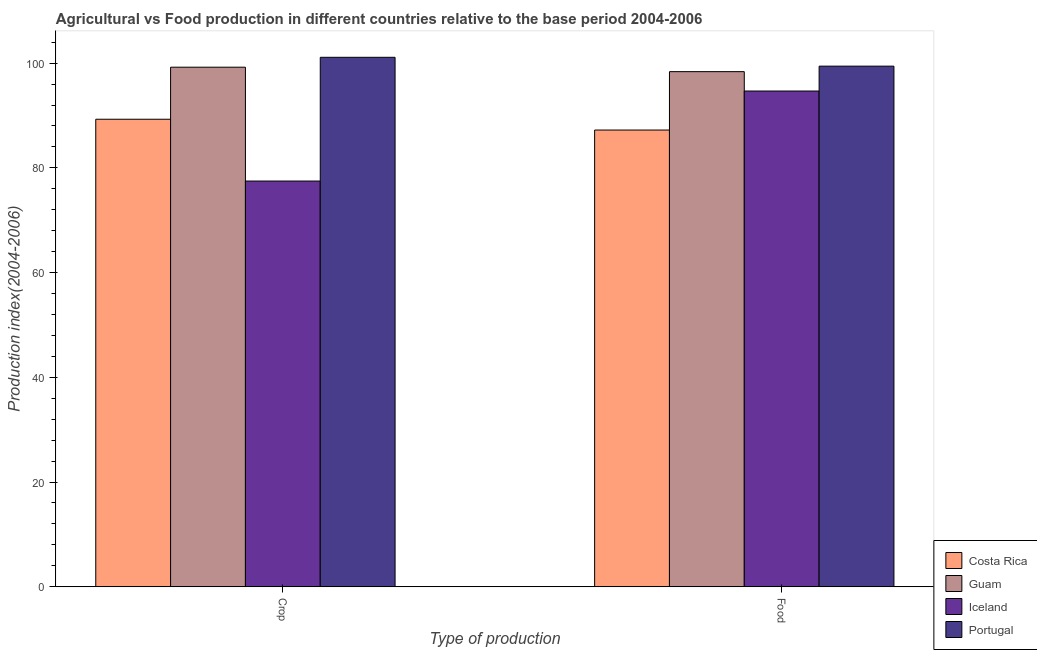Are the number of bars on each tick of the X-axis equal?
Your answer should be compact. Yes. How many bars are there on the 2nd tick from the right?
Offer a very short reply. 4. What is the label of the 2nd group of bars from the left?
Keep it short and to the point. Food. What is the food production index in Guam?
Make the answer very short. 98.37. Across all countries, what is the maximum crop production index?
Your response must be concise. 101.11. Across all countries, what is the minimum crop production index?
Provide a short and direct response. 77.48. What is the total crop production index in the graph?
Your answer should be compact. 367.09. What is the difference between the crop production index in Guam and that in Iceland?
Provide a succinct answer. 21.74. What is the difference between the food production index in Costa Rica and the crop production index in Guam?
Give a very brief answer. -12. What is the average crop production index per country?
Your answer should be compact. 91.77. What is the difference between the food production index and crop production index in Guam?
Offer a very short reply. -0.85. In how many countries, is the crop production index greater than 68 ?
Give a very brief answer. 4. What is the ratio of the food production index in Costa Rica to that in Iceland?
Keep it short and to the point. 0.92. Is the food production index in Guam less than that in Portugal?
Give a very brief answer. Yes. In how many countries, is the food production index greater than the average food production index taken over all countries?
Ensure brevity in your answer.  2. What does the 3rd bar from the left in Crop represents?
Offer a terse response. Iceland. Are all the bars in the graph horizontal?
Your answer should be very brief. No. How many countries are there in the graph?
Your answer should be compact. 4. Are the values on the major ticks of Y-axis written in scientific E-notation?
Offer a very short reply. No. How many legend labels are there?
Give a very brief answer. 4. What is the title of the graph?
Offer a terse response. Agricultural vs Food production in different countries relative to the base period 2004-2006. What is the label or title of the X-axis?
Make the answer very short. Type of production. What is the label or title of the Y-axis?
Make the answer very short. Production index(2004-2006). What is the Production index(2004-2006) in Costa Rica in Crop?
Give a very brief answer. 89.28. What is the Production index(2004-2006) of Guam in Crop?
Your response must be concise. 99.22. What is the Production index(2004-2006) in Iceland in Crop?
Give a very brief answer. 77.48. What is the Production index(2004-2006) in Portugal in Crop?
Provide a short and direct response. 101.11. What is the Production index(2004-2006) of Costa Rica in Food?
Make the answer very short. 87.22. What is the Production index(2004-2006) in Guam in Food?
Offer a very short reply. 98.37. What is the Production index(2004-2006) in Iceland in Food?
Offer a very short reply. 94.67. What is the Production index(2004-2006) in Portugal in Food?
Provide a succinct answer. 99.42. Across all Type of production, what is the maximum Production index(2004-2006) of Costa Rica?
Give a very brief answer. 89.28. Across all Type of production, what is the maximum Production index(2004-2006) in Guam?
Offer a terse response. 99.22. Across all Type of production, what is the maximum Production index(2004-2006) of Iceland?
Provide a succinct answer. 94.67. Across all Type of production, what is the maximum Production index(2004-2006) of Portugal?
Keep it short and to the point. 101.11. Across all Type of production, what is the minimum Production index(2004-2006) in Costa Rica?
Your answer should be very brief. 87.22. Across all Type of production, what is the minimum Production index(2004-2006) of Guam?
Offer a terse response. 98.37. Across all Type of production, what is the minimum Production index(2004-2006) of Iceland?
Provide a short and direct response. 77.48. Across all Type of production, what is the minimum Production index(2004-2006) in Portugal?
Your response must be concise. 99.42. What is the total Production index(2004-2006) in Costa Rica in the graph?
Offer a very short reply. 176.5. What is the total Production index(2004-2006) of Guam in the graph?
Provide a succinct answer. 197.59. What is the total Production index(2004-2006) of Iceland in the graph?
Your answer should be very brief. 172.15. What is the total Production index(2004-2006) in Portugal in the graph?
Your answer should be very brief. 200.53. What is the difference between the Production index(2004-2006) in Costa Rica in Crop and that in Food?
Your response must be concise. 2.06. What is the difference between the Production index(2004-2006) in Iceland in Crop and that in Food?
Provide a succinct answer. -17.19. What is the difference between the Production index(2004-2006) in Portugal in Crop and that in Food?
Offer a very short reply. 1.69. What is the difference between the Production index(2004-2006) in Costa Rica in Crop and the Production index(2004-2006) in Guam in Food?
Offer a terse response. -9.09. What is the difference between the Production index(2004-2006) of Costa Rica in Crop and the Production index(2004-2006) of Iceland in Food?
Offer a terse response. -5.39. What is the difference between the Production index(2004-2006) in Costa Rica in Crop and the Production index(2004-2006) in Portugal in Food?
Provide a succinct answer. -10.14. What is the difference between the Production index(2004-2006) in Guam in Crop and the Production index(2004-2006) in Iceland in Food?
Your response must be concise. 4.55. What is the difference between the Production index(2004-2006) in Guam in Crop and the Production index(2004-2006) in Portugal in Food?
Make the answer very short. -0.2. What is the difference between the Production index(2004-2006) of Iceland in Crop and the Production index(2004-2006) of Portugal in Food?
Ensure brevity in your answer.  -21.94. What is the average Production index(2004-2006) of Costa Rica per Type of production?
Provide a short and direct response. 88.25. What is the average Production index(2004-2006) of Guam per Type of production?
Make the answer very short. 98.8. What is the average Production index(2004-2006) in Iceland per Type of production?
Your answer should be very brief. 86.08. What is the average Production index(2004-2006) in Portugal per Type of production?
Provide a succinct answer. 100.27. What is the difference between the Production index(2004-2006) of Costa Rica and Production index(2004-2006) of Guam in Crop?
Your response must be concise. -9.94. What is the difference between the Production index(2004-2006) of Costa Rica and Production index(2004-2006) of Portugal in Crop?
Your answer should be compact. -11.83. What is the difference between the Production index(2004-2006) in Guam and Production index(2004-2006) in Iceland in Crop?
Provide a succinct answer. 21.74. What is the difference between the Production index(2004-2006) in Guam and Production index(2004-2006) in Portugal in Crop?
Offer a terse response. -1.89. What is the difference between the Production index(2004-2006) in Iceland and Production index(2004-2006) in Portugal in Crop?
Provide a succinct answer. -23.63. What is the difference between the Production index(2004-2006) in Costa Rica and Production index(2004-2006) in Guam in Food?
Your response must be concise. -11.15. What is the difference between the Production index(2004-2006) in Costa Rica and Production index(2004-2006) in Iceland in Food?
Give a very brief answer. -7.45. What is the difference between the Production index(2004-2006) in Guam and Production index(2004-2006) in Iceland in Food?
Give a very brief answer. 3.7. What is the difference between the Production index(2004-2006) in Guam and Production index(2004-2006) in Portugal in Food?
Ensure brevity in your answer.  -1.05. What is the difference between the Production index(2004-2006) of Iceland and Production index(2004-2006) of Portugal in Food?
Your response must be concise. -4.75. What is the ratio of the Production index(2004-2006) in Costa Rica in Crop to that in Food?
Keep it short and to the point. 1.02. What is the ratio of the Production index(2004-2006) in Guam in Crop to that in Food?
Your answer should be very brief. 1.01. What is the ratio of the Production index(2004-2006) of Iceland in Crop to that in Food?
Ensure brevity in your answer.  0.82. What is the ratio of the Production index(2004-2006) of Portugal in Crop to that in Food?
Your answer should be very brief. 1.02. What is the difference between the highest and the second highest Production index(2004-2006) of Costa Rica?
Your response must be concise. 2.06. What is the difference between the highest and the second highest Production index(2004-2006) of Guam?
Your response must be concise. 0.85. What is the difference between the highest and the second highest Production index(2004-2006) in Iceland?
Provide a succinct answer. 17.19. What is the difference between the highest and the second highest Production index(2004-2006) in Portugal?
Give a very brief answer. 1.69. What is the difference between the highest and the lowest Production index(2004-2006) in Costa Rica?
Provide a short and direct response. 2.06. What is the difference between the highest and the lowest Production index(2004-2006) of Guam?
Offer a very short reply. 0.85. What is the difference between the highest and the lowest Production index(2004-2006) of Iceland?
Ensure brevity in your answer.  17.19. What is the difference between the highest and the lowest Production index(2004-2006) of Portugal?
Your answer should be compact. 1.69. 